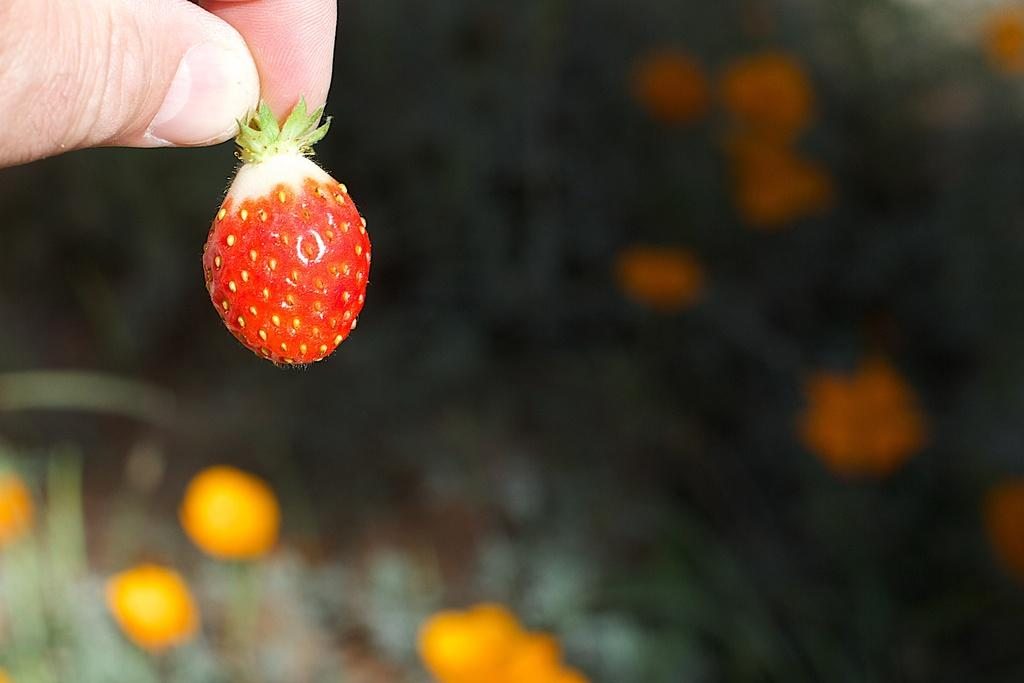What is the main subject of the image? There is a human in the image. What is the human holding in the image? The human is holding a strawberry. What can be said about the color of the strawberry? The strawberry is red in color. Can you tell me how many tigers are in the image? There are no tigers present in the image. Is the carpenter working on a drawer in the image? There is no carpenter or drawer present in the image. 